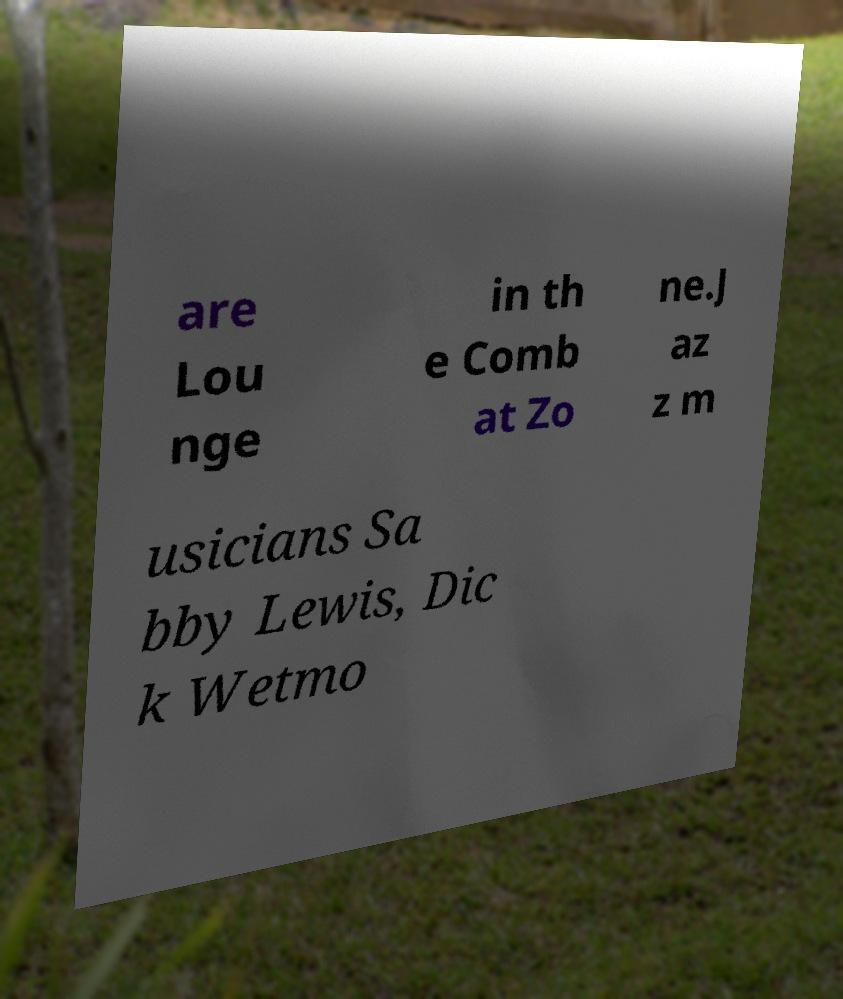Can you read and provide the text displayed in the image?This photo seems to have some interesting text. Can you extract and type it out for me? are Lou nge in th e Comb at Zo ne.J az z m usicians Sa bby Lewis, Dic k Wetmo 